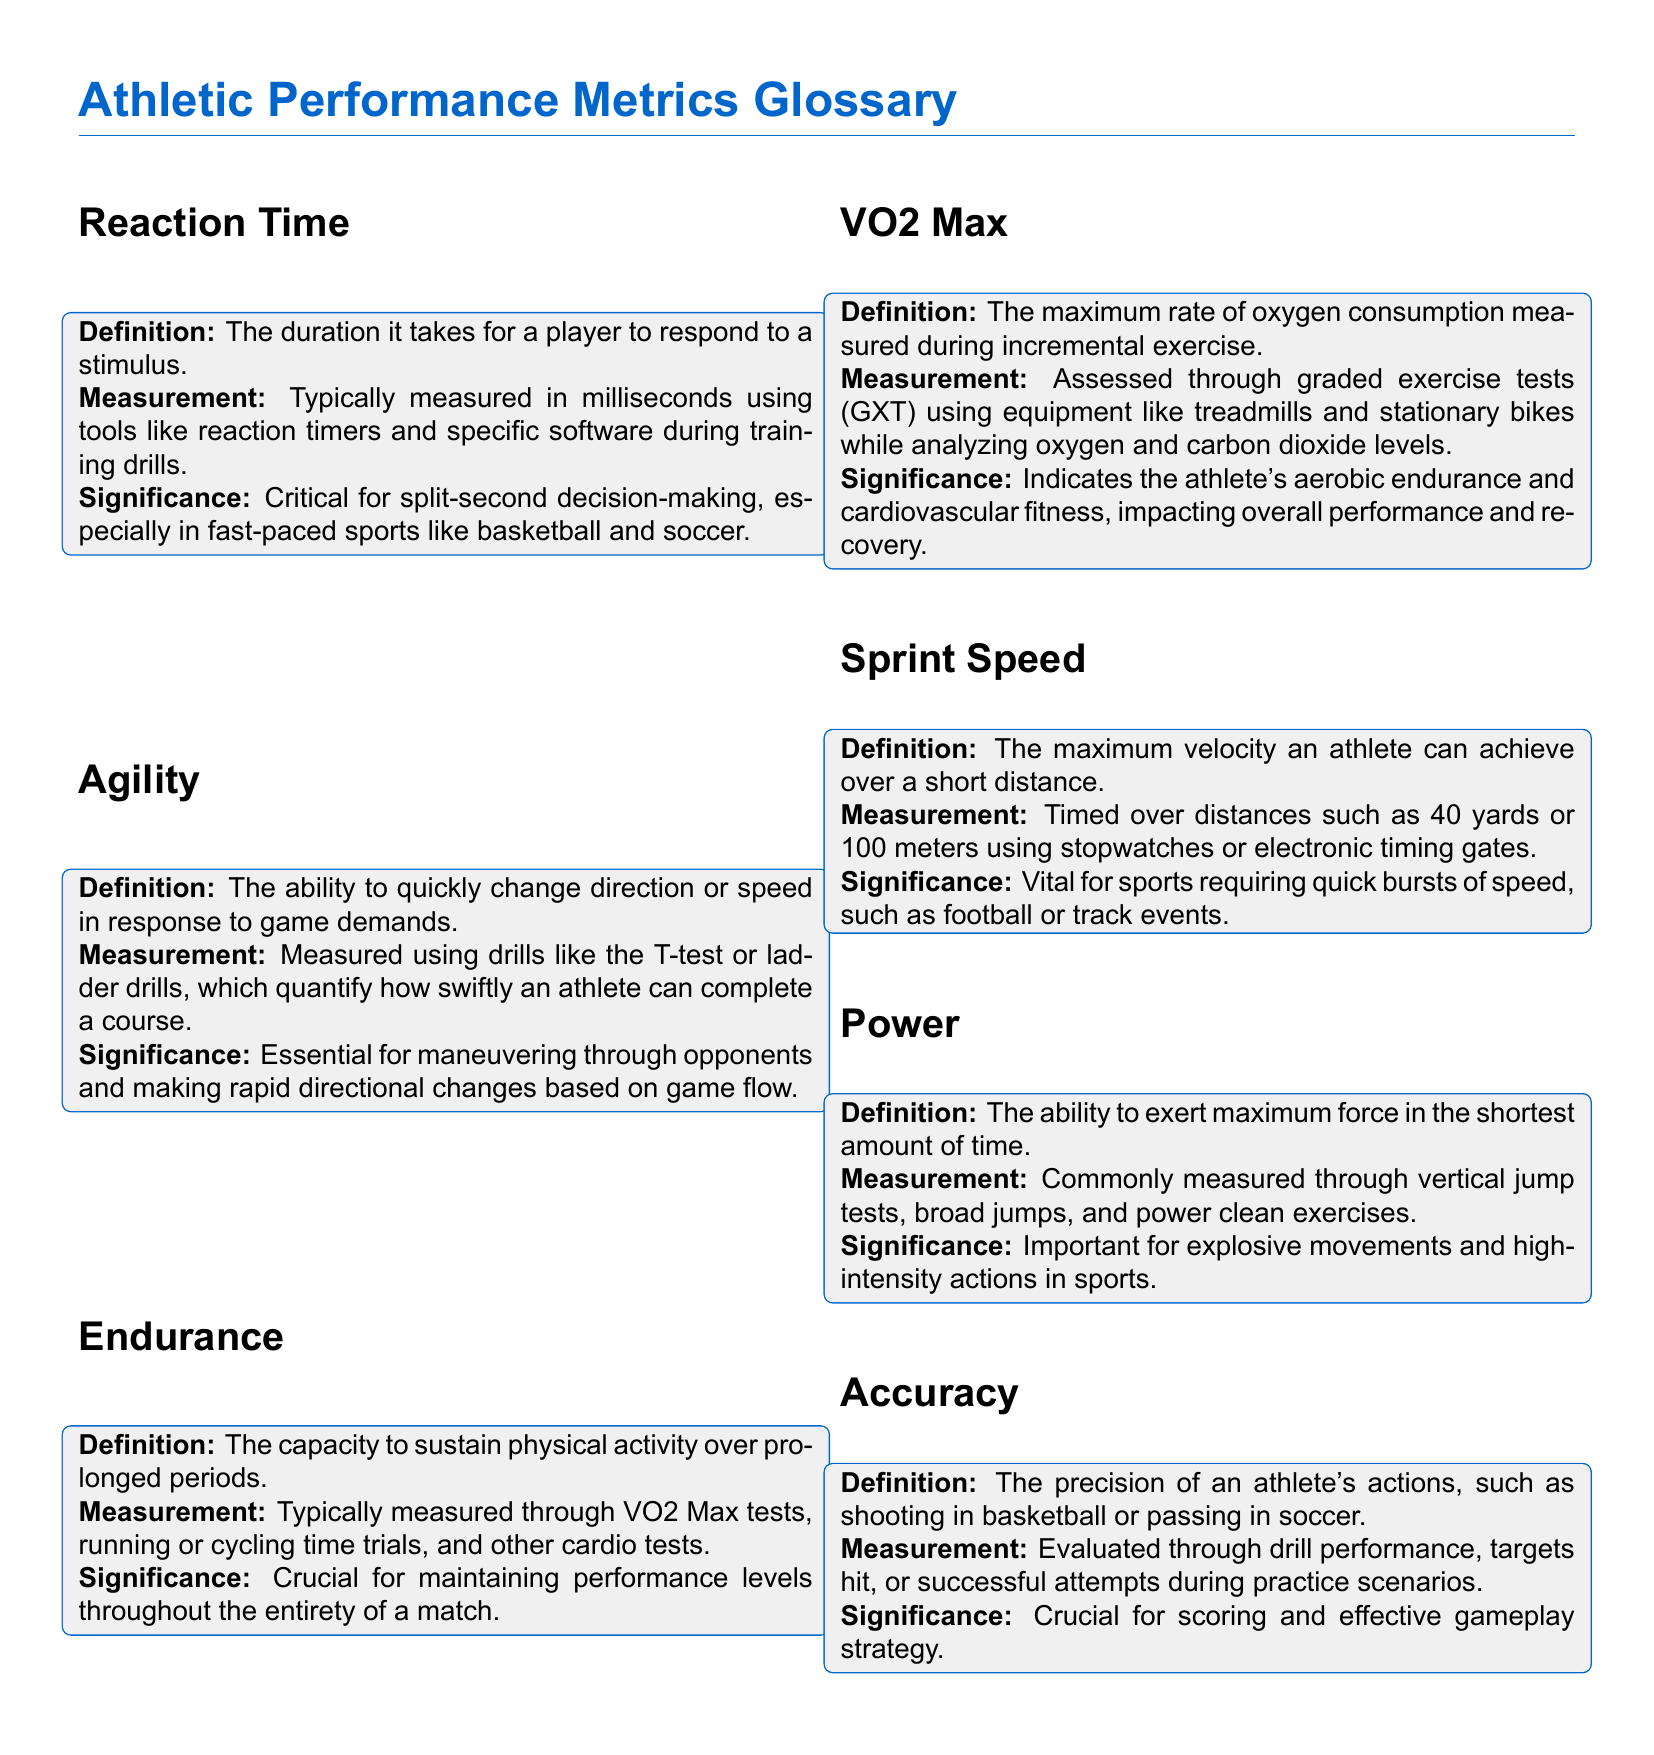What is the definition of Reaction Time? Reaction Time is defined as the duration it takes for a player to respond to a stimulus.
Answer: duration it takes for a player to respond to a stimulus How is Agility measured? Agility is measured using drills like the T-test or ladder drills, which quantify how swiftly an athlete can complete a course.
Answer: T-test or ladder drills What does VO2 Max indicate? VO2 Max indicates the athlete's aerobic endurance and cardiovascular fitness.
Answer: aerobic endurance and cardiovascular fitness What is the significance of Endurance? Endurance is crucial for maintaining performance levels throughout the entirety of a match.
Answer: maintaining performance levels throughout the match What tools are used to measure Reaction Time? Reaction Time is typically measured using tools like reaction timers and specific software during training drills.
Answer: reaction timers and specific software What is the maximum distance for measuring Sprint Speed mentioned? The maximum distance mentioned for measuring Sprint Speed is 100 meters.
Answer: 100 meters Which performance metric is assessed through graded exercise tests? VO2 Max is assessed through graded exercise tests.
Answer: VO2 Max What does Power measure? Power measures the ability to exert maximum force in the shortest amount of time.
Answer: ability to exert maximum force in the shortest amount of time What is the primary focus of Accuracy in athletic performance? Accuracy focuses on the precision of an athlete's actions, such as shooting in basketball or passing in soccer.
Answer: precision of an athlete's actions 